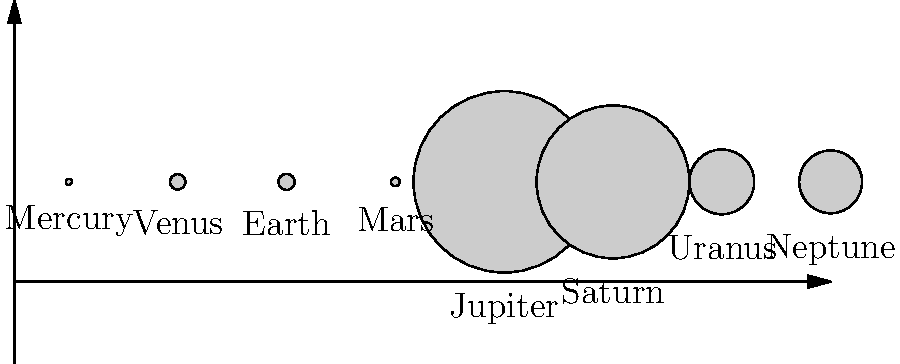Given the comparative scale diagram of planets in our solar system, which planet's size could potentially have the most significant impact on cognitive function and brain adaptation for long-term space missions, and why? To answer this question, we need to consider several factors:

1. Size of the planet: Larger planets have stronger gravitational fields, which would have a more pronounced effect on the human body and brain.

2. Gravitational effects: The difference in gravity between Earth and the destination planet is crucial for understanding potential cognitive and physiological adaptations.

3. Long-term space missions: We need to consider planets that are feasible targets for extended human exploration.

Analyzing the diagram:

1. Jupiter is clearly the largest planet, followed by Saturn, Uranus, and Neptune.

2. Earth is the largest of the terrestrial planets (Mercury, Venus, Earth, Mars).

3. Mars is significantly smaller than Earth but is a prime candidate for long-term space missions.

Considering these factors:

1. Jupiter's immense size suggests an extremely strong gravitational field, which would be detrimental to human physiology and cognition. However, it's not a feasible destination for long-term human missions due to its gaseous nature.

2. Mars, despite being smaller than Earth, is the most likely candidate for long-term space missions. The significant difference in gravity (about 38% of Earth's) would have a notable impact on cognitive function and brain adaptation.

3. The reduced gravity on Mars would affect:
   a) Fluid shift in the body, potentially impacting intracranial pressure and cerebral blood flow.
   b) Vestibular system functioning, affecting balance and spatial orientation.
   c) Bone density and muscle mass, which could indirectly affect cognitive performance.
   d) Sensory-motor adaptation, requiring significant brain plasticity.

4. The long-term effects of Martian gravity on cognitive function would be a critical area of study for neuroscientists planning extended missions to Mars.
Answer: Mars, due to its feasibility for long-term missions and significantly reduced gravity compared to Earth. 